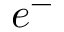Convert formula to latex. <formula><loc_0><loc_0><loc_500><loc_500>e ^ { - }</formula> 